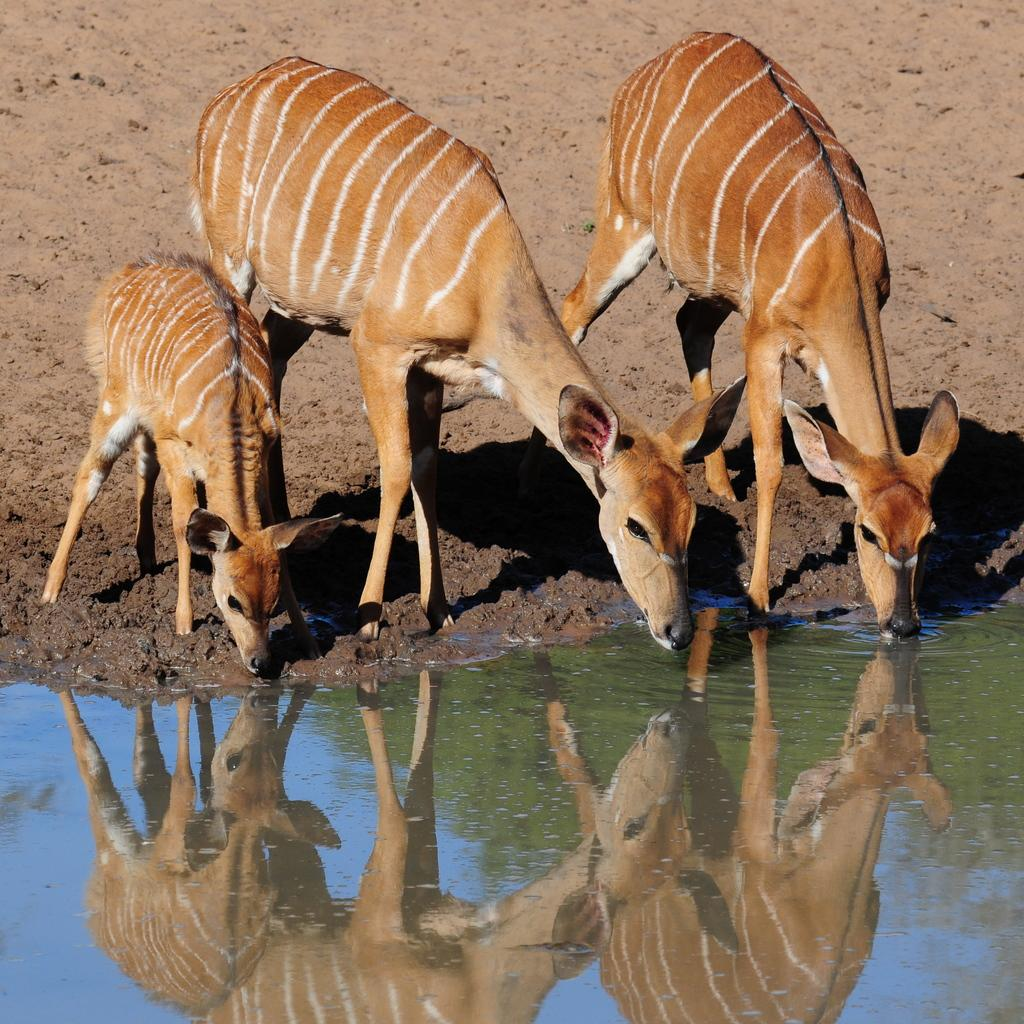What types of living organisms can be seen in the image? Animals are visible in the image. Where are the animals located? The animals are on the surface. What type of leaf is being used by the animals to take a selfie in the image? There is no leaf or selfie present in the image; it only features animals on the surface. 